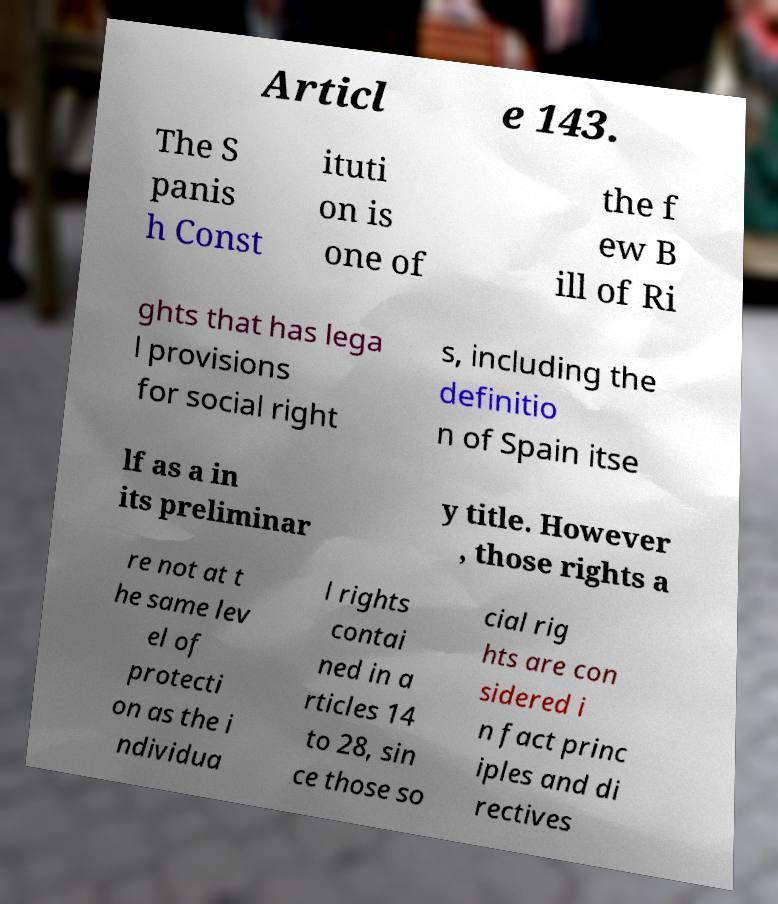Could you extract and type out the text from this image? Articl e 143. The S panis h Const ituti on is one of the f ew B ill of Ri ghts that has lega l provisions for social right s, including the definitio n of Spain itse lf as a in its preliminar y title. However , those rights a re not at t he same lev el of protecti on as the i ndividua l rights contai ned in a rticles 14 to 28, sin ce those so cial rig hts are con sidered i n fact princ iples and di rectives 